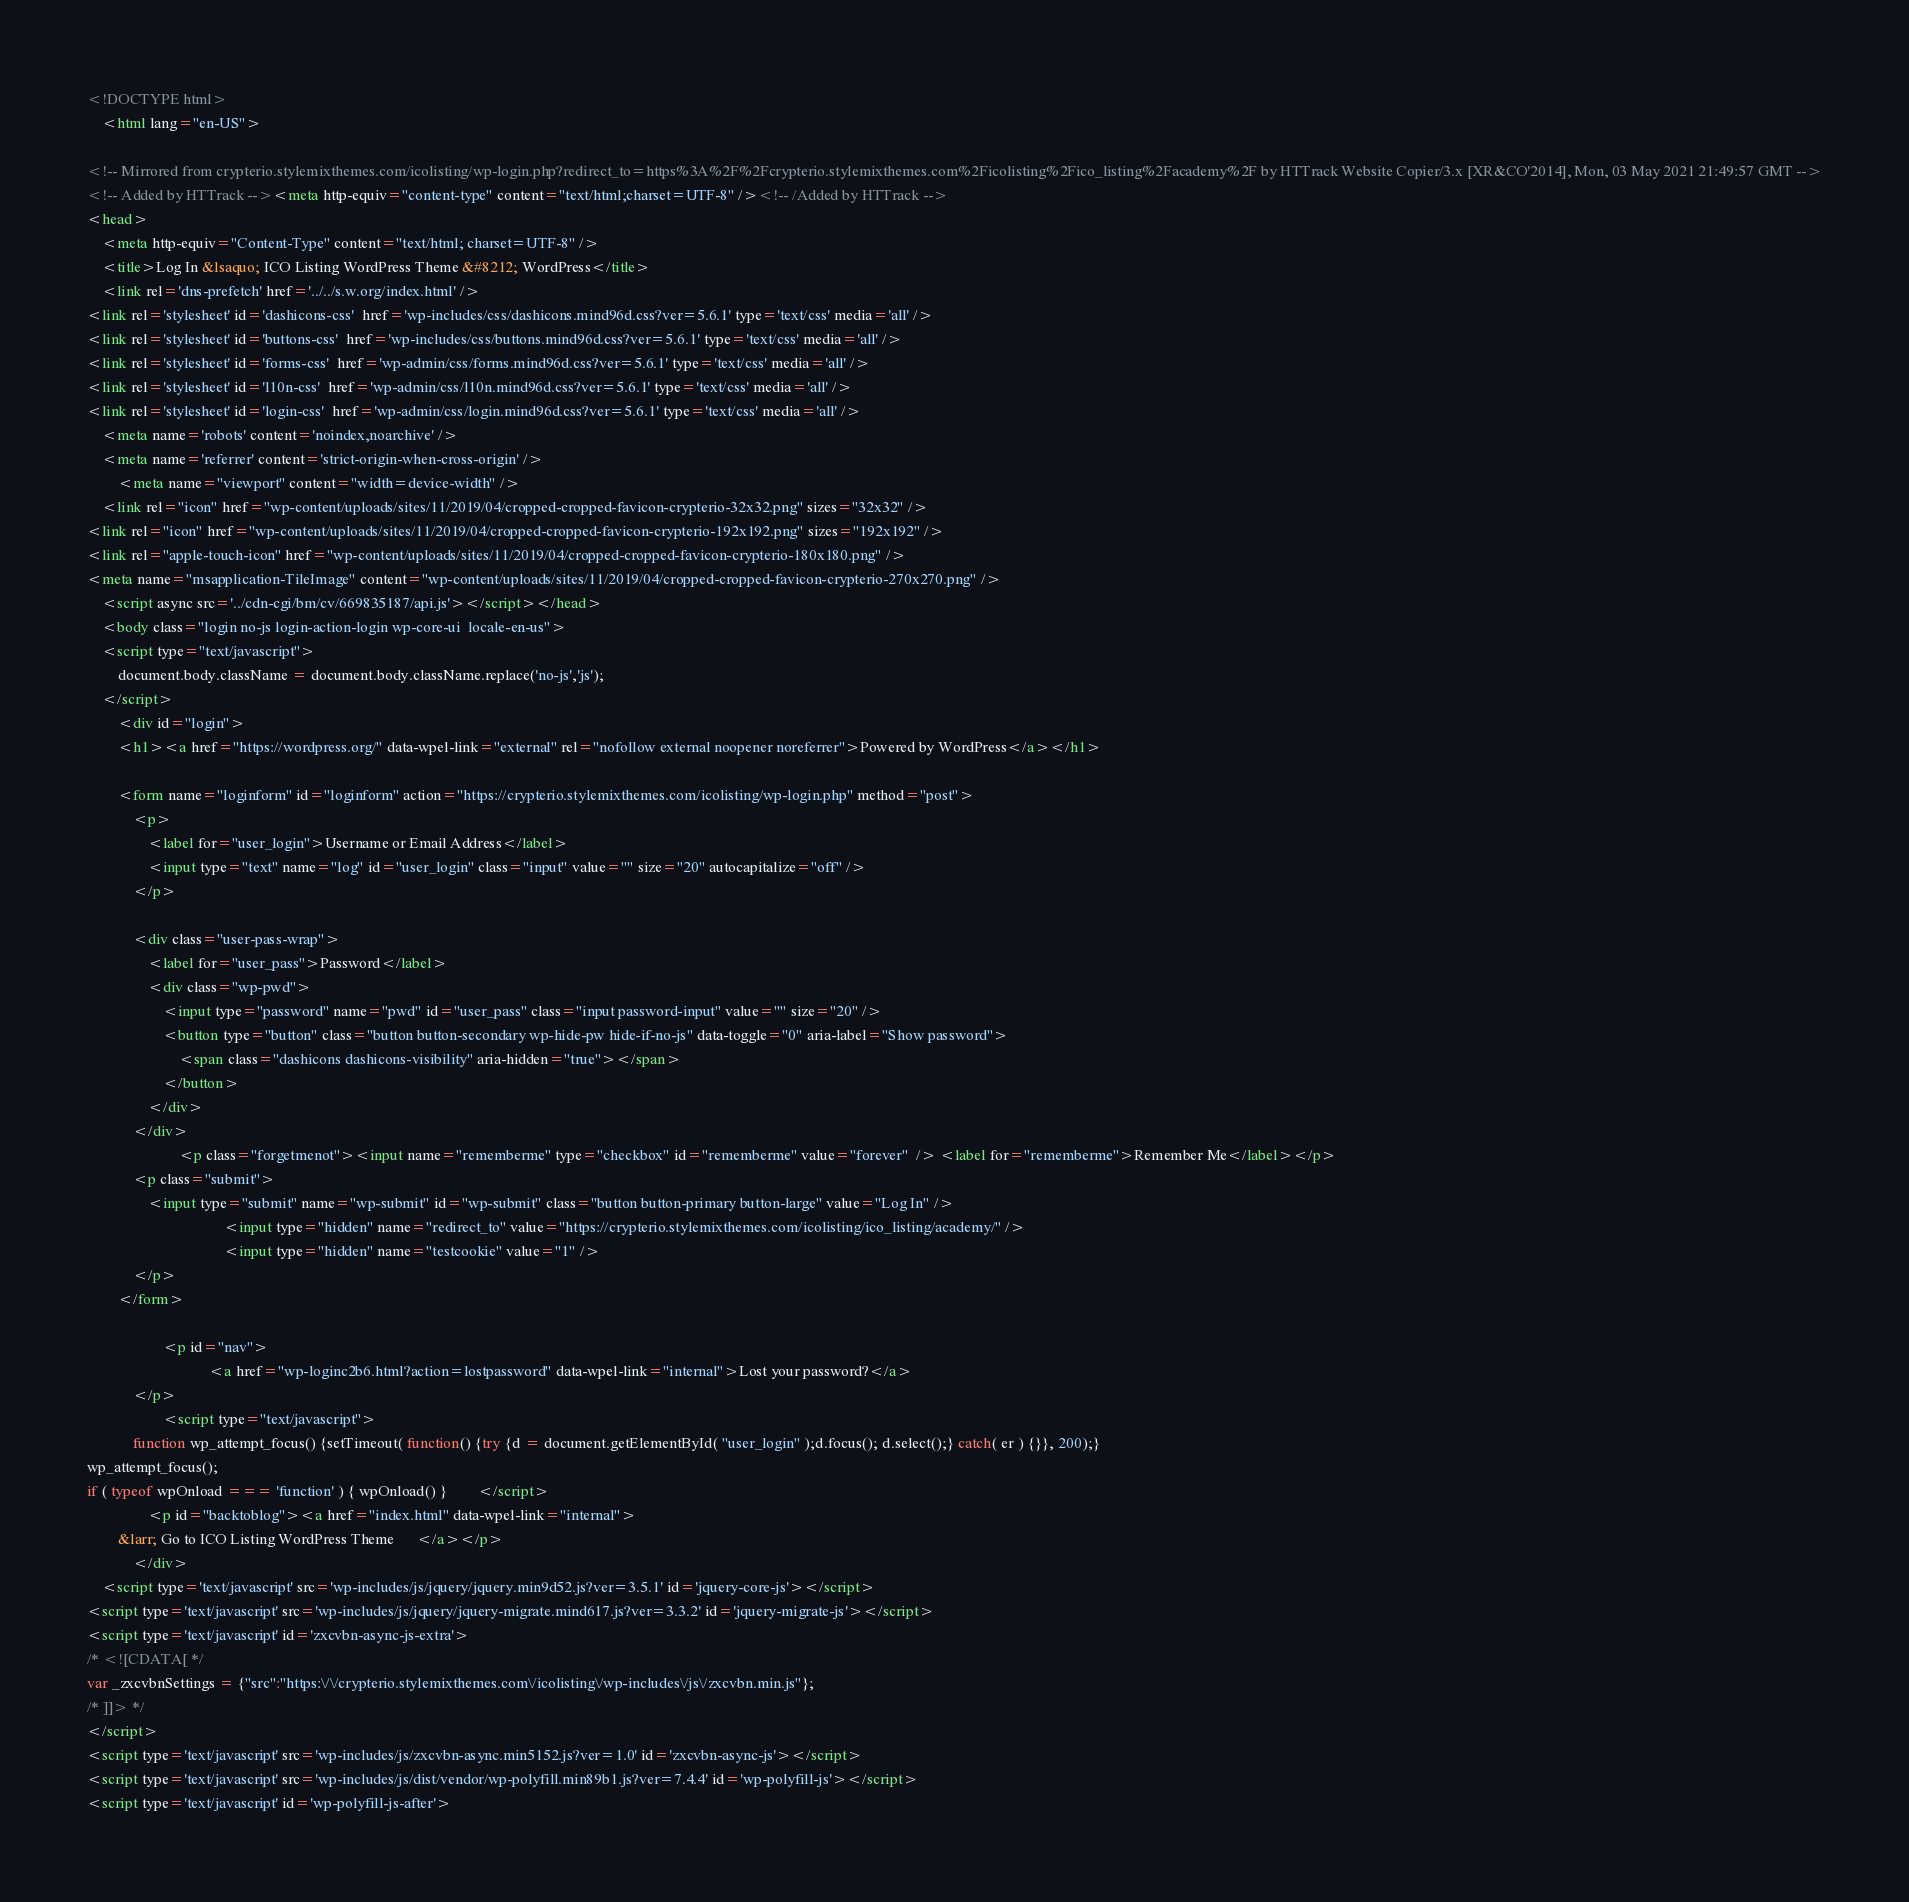Convert code to text. <code><loc_0><loc_0><loc_500><loc_500><_HTML_><!DOCTYPE html>
	<html lang="en-US">
	
<!-- Mirrored from crypterio.stylemixthemes.com/icolisting/wp-login.php?redirect_to=https%3A%2F%2Fcrypterio.stylemixthemes.com%2Ficolisting%2Fico_listing%2Facademy%2F by HTTrack Website Copier/3.x [XR&CO'2014], Mon, 03 May 2021 21:49:57 GMT -->
<!-- Added by HTTrack --><meta http-equiv="content-type" content="text/html;charset=UTF-8" /><!-- /Added by HTTrack -->
<head>
	<meta http-equiv="Content-Type" content="text/html; charset=UTF-8" />
	<title>Log In &lsaquo; ICO Listing WordPress Theme &#8212; WordPress</title>
	<link rel='dns-prefetch' href='../../s.w.org/index.html' />
<link rel='stylesheet' id='dashicons-css'  href='wp-includes/css/dashicons.mind96d.css?ver=5.6.1' type='text/css' media='all' />
<link rel='stylesheet' id='buttons-css'  href='wp-includes/css/buttons.mind96d.css?ver=5.6.1' type='text/css' media='all' />
<link rel='stylesheet' id='forms-css'  href='wp-admin/css/forms.mind96d.css?ver=5.6.1' type='text/css' media='all' />
<link rel='stylesheet' id='l10n-css'  href='wp-admin/css/l10n.mind96d.css?ver=5.6.1' type='text/css' media='all' />
<link rel='stylesheet' id='login-css'  href='wp-admin/css/login.mind96d.css?ver=5.6.1' type='text/css' media='all' />
	<meta name='robots' content='noindex,noarchive' />
	<meta name='referrer' content='strict-origin-when-cross-origin' />
		<meta name="viewport" content="width=device-width" />
	<link rel="icon" href="wp-content/uploads/sites/11/2019/04/cropped-cropped-favicon-crypterio-32x32.png" sizes="32x32" />
<link rel="icon" href="wp-content/uploads/sites/11/2019/04/cropped-cropped-favicon-crypterio-192x192.png" sizes="192x192" />
<link rel="apple-touch-icon" href="wp-content/uploads/sites/11/2019/04/cropped-cropped-favicon-crypterio-180x180.png" />
<meta name="msapplication-TileImage" content="wp-content/uploads/sites/11/2019/04/cropped-cropped-favicon-crypterio-270x270.png" />
	<script async src='../cdn-cgi/bm/cv/669835187/api.js'></script></head>
	<body class="login no-js login-action-login wp-core-ui  locale-en-us">
	<script type="text/javascript">
		document.body.className = document.body.className.replace('no-js','js');
	</script>
		<div id="login">
		<h1><a href="https://wordpress.org/" data-wpel-link="external" rel="nofollow external noopener noreferrer">Powered by WordPress</a></h1>
	
		<form name="loginform" id="loginform" action="https://crypterio.stylemixthemes.com/icolisting/wp-login.php" method="post">
			<p>
				<label for="user_login">Username or Email Address</label>
				<input type="text" name="log" id="user_login" class="input" value="" size="20" autocapitalize="off" />
			</p>

			<div class="user-pass-wrap">
				<label for="user_pass">Password</label>
				<div class="wp-pwd">
					<input type="password" name="pwd" id="user_pass" class="input password-input" value="" size="20" />
					<button type="button" class="button button-secondary wp-hide-pw hide-if-no-js" data-toggle="0" aria-label="Show password">
						<span class="dashicons dashicons-visibility" aria-hidden="true"></span>
					</button>
				</div>
			</div>
						<p class="forgetmenot"><input name="rememberme" type="checkbox" id="rememberme" value="forever"  /> <label for="rememberme">Remember Me</label></p>
			<p class="submit">
				<input type="submit" name="wp-submit" id="wp-submit" class="button button-primary button-large" value="Log In" />
									<input type="hidden" name="redirect_to" value="https://crypterio.stylemixthemes.com/icolisting/ico_listing/academy/" />
									<input type="hidden" name="testcookie" value="1" />
			</p>
		</form>

					<p id="nav">
								<a href="wp-loginc2b6.html?action=lostpassword" data-wpel-link="internal">Lost your password?</a>
			</p>
					<script type="text/javascript">
			function wp_attempt_focus() {setTimeout( function() {try {d = document.getElementById( "user_login" );d.focus(); d.select();} catch( er ) {}}, 200);}
wp_attempt_focus();
if ( typeof wpOnload === 'function' ) { wpOnload() }		</script>
				<p id="backtoblog"><a href="index.html" data-wpel-link="internal">
		&larr; Go to ICO Listing WordPress Theme		</a></p>
			</div>
	<script type='text/javascript' src='wp-includes/js/jquery/jquery.min9d52.js?ver=3.5.1' id='jquery-core-js'></script>
<script type='text/javascript' src='wp-includes/js/jquery/jquery-migrate.mind617.js?ver=3.3.2' id='jquery-migrate-js'></script>
<script type='text/javascript' id='zxcvbn-async-js-extra'>
/* <![CDATA[ */
var _zxcvbnSettings = {"src":"https:\/\/crypterio.stylemixthemes.com\/icolisting\/wp-includes\/js\/zxcvbn.min.js"};
/* ]]> */
</script>
<script type='text/javascript' src='wp-includes/js/zxcvbn-async.min5152.js?ver=1.0' id='zxcvbn-async-js'></script>
<script type='text/javascript' src='wp-includes/js/dist/vendor/wp-polyfill.min89b1.js?ver=7.4.4' id='wp-polyfill-js'></script>
<script type='text/javascript' id='wp-polyfill-js-after'></code> 